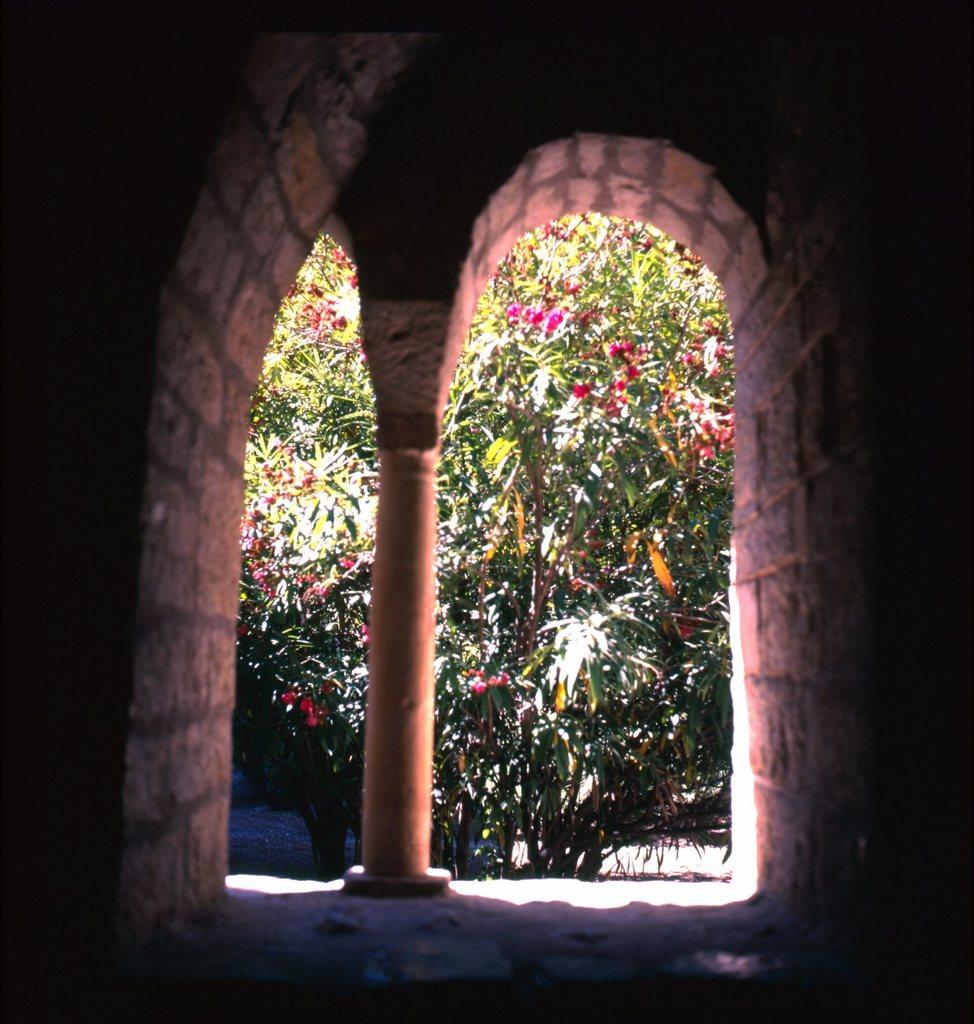What type of structure is visible in the image? There is a stone wall in the image. What other architectural feature can be seen in the image? There is a pillar in the image. What can be seen in the background of the image? There are trees and flowers in the background of the image. What is the color of the flowers in the image? The flowers are pink in color. How does the stone wall express regret in the image? The stone wall does not express regret, as it is an inanimate object and cannot have emotions or express feelings. 